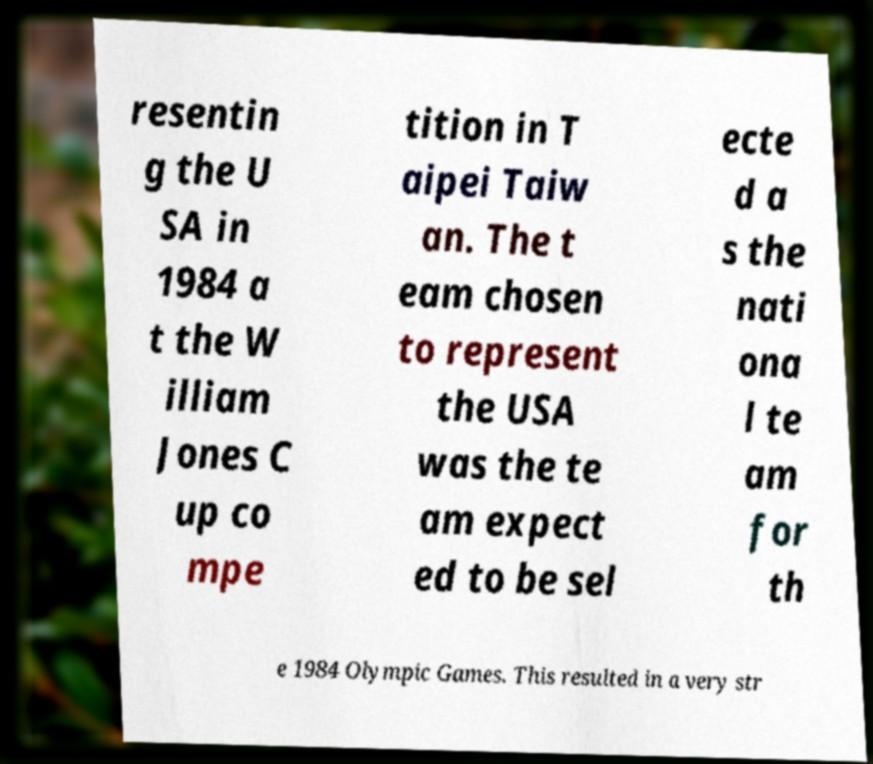Can you accurately transcribe the text from the provided image for me? resentin g the U SA in 1984 a t the W illiam Jones C up co mpe tition in T aipei Taiw an. The t eam chosen to represent the USA was the te am expect ed to be sel ecte d a s the nati ona l te am for th e 1984 Olympic Games. This resulted in a very str 